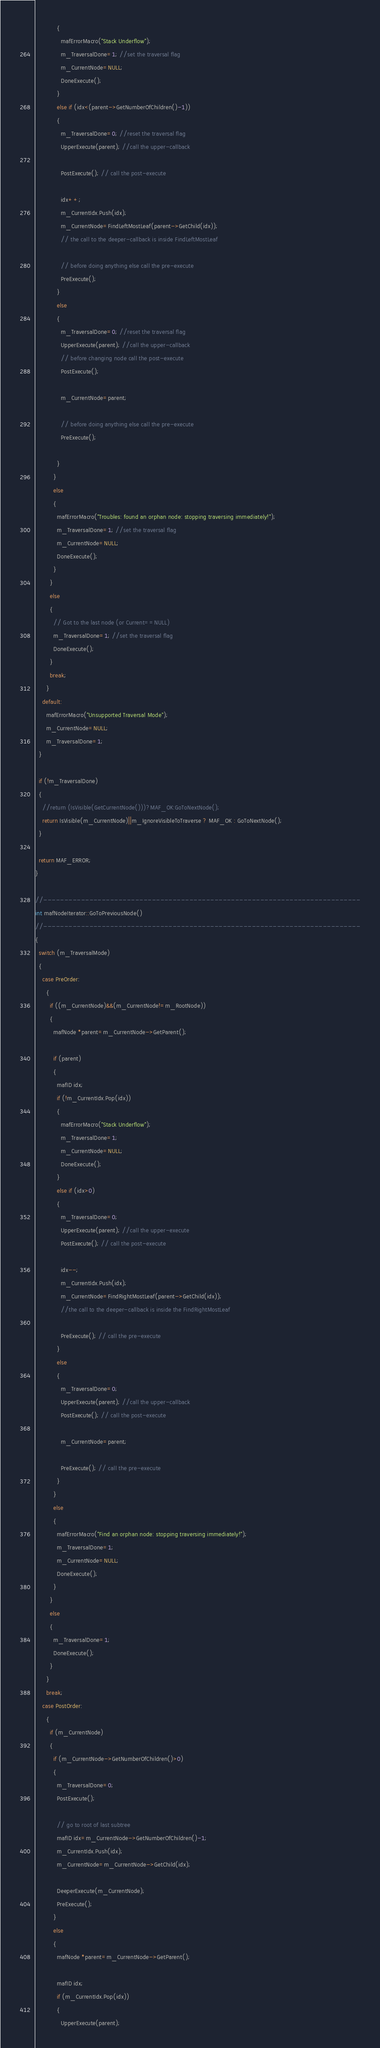<code> <loc_0><loc_0><loc_500><loc_500><_C++_>            {
              mafErrorMacro("Stack Underflow");
              m_TraversalDone=1; //set the traversal flag
              m_CurrentNode=NULL;
              DoneExecute();
            }
            else if (idx<(parent->GetNumberOfChildren()-1))
            {
              m_TraversalDone=0; //reset the traversal flag
              UpperExecute(parent); //call the upper-callback

              PostExecute(); // call the post-execute

              idx++;
              m_CurrentIdx.Push(idx);
              m_CurrentNode=FindLeftMostLeaf(parent->GetChild(idx));
              // the call to the deeper-callback is inside FindLeftMostLeaf

              // before doing anything else call the pre-execute
              PreExecute();
            }
            else
            {
              m_TraversalDone=0; //reset the traversal flag
              UpperExecute(parent); //call the upper-callback
              // before changing node call the post-execute
              PostExecute();

              m_CurrentNode=parent;

              // before doing anything else call the pre-execute
              PreExecute();

            }
          }
          else
          {
            mafErrorMacro("Troubles: found an orphan node: stopping traversing immediately!");
            m_TraversalDone=1; //set the traversal flag
            m_CurrentNode=NULL;
            DoneExecute();
          }
        }
        else
        {
          // Got to the last node (or Current==NULL)
          m_TraversalDone=1; //set the traversal flag
          DoneExecute();
        }
        break;
      }
    default:
      mafErrorMacro("Unsupported Traversal Mode");
      m_CurrentNode=NULL;
      m_TraversalDone=1;
  }

  if (!m_TraversalDone)
  {
    //return (IsVisible(GetCurrentNode()))?MAF_OK:GoToNextNode();
    return IsVisible(m_CurrentNode)||m_IgnoreVisibleToTraverse ? MAF_OK : GoToNextNode();
  }

  return MAF_ERROR;
}

//----------------------------------------------------------------------------
int mafNodeIterator::GoToPreviousNode()
//----------------------------------------------------------------------------
{
  switch (m_TraversalMode)
  {
    case PreOrder:
      {
        if ((m_CurrentNode)&&(m_CurrentNode!=m_RootNode))
        {
          mafNode *parent=m_CurrentNode->GetParent();

          if (parent)
          {
            mafID idx;
            if (!m_CurrentIdx.Pop(idx))
            {
              mafErrorMacro("Stack Underflow");
              m_TraversalDone=1;
              m_CurrentNode=NULL;
              DoneExecute();
            }
            else if (idx>0)
            {
              m_TraversalDone=0;
              UpperExecute(parent); //call the upper-execute
              PostExecute(); // call the post-execute

              idx--;
              m_CurrentIdx.Push(idx);
              m_CurrentNode=FindRightMostLeaf(parent->GetChild(idx));
              //the call to the deeper-callback is inside the FindRightMostLeaf
              
              PreExecute(); // call the pre-execute
            }
            else
            {
              m_TraversalDone=0;
              UpperExecute(parent); //call the upper-callback
              PostExecute(); // call the post-execute

              m_CurrentNode=parent;

              PreExecute(); // call the pre-execute
            }
          }
          else
          {
            mafErrorMacro("Find an orphan node: stopping traversing immediately!");
            m_TraversalDone=1;
            m_CurrentNode=NULL;
            DoneExecute();
          }
        }
        else
        {
          m_TraversalDone=1;
          DoneExecute();
        }
      }
      break;
    case PostOrder:
      {
        if (m_CurrentNode)
        {
          if (m_CurrentNode->GetNumberOfChildren()>0)
          {
            m_TraversalDone=0;
            PostExecute(); 

            // go to root of last subtree
            mafID idx=m_CurrentNode->GetNumberOfChildren()-1;
            m_CurrentIdx.Push(idx);
            m_CurrentNode=m_CurrentNode->GetChild(idx);

            DeeperExecute(m_CurrentNode);
            PreExecute();
          }
          else
          {
            mafNode *parent=m_CurrentNode->GetParent();

            mafID idx;
            if (m_CurrentIdx.Pop(idx))
            {
              UpperExecute(parent); 
</code> 